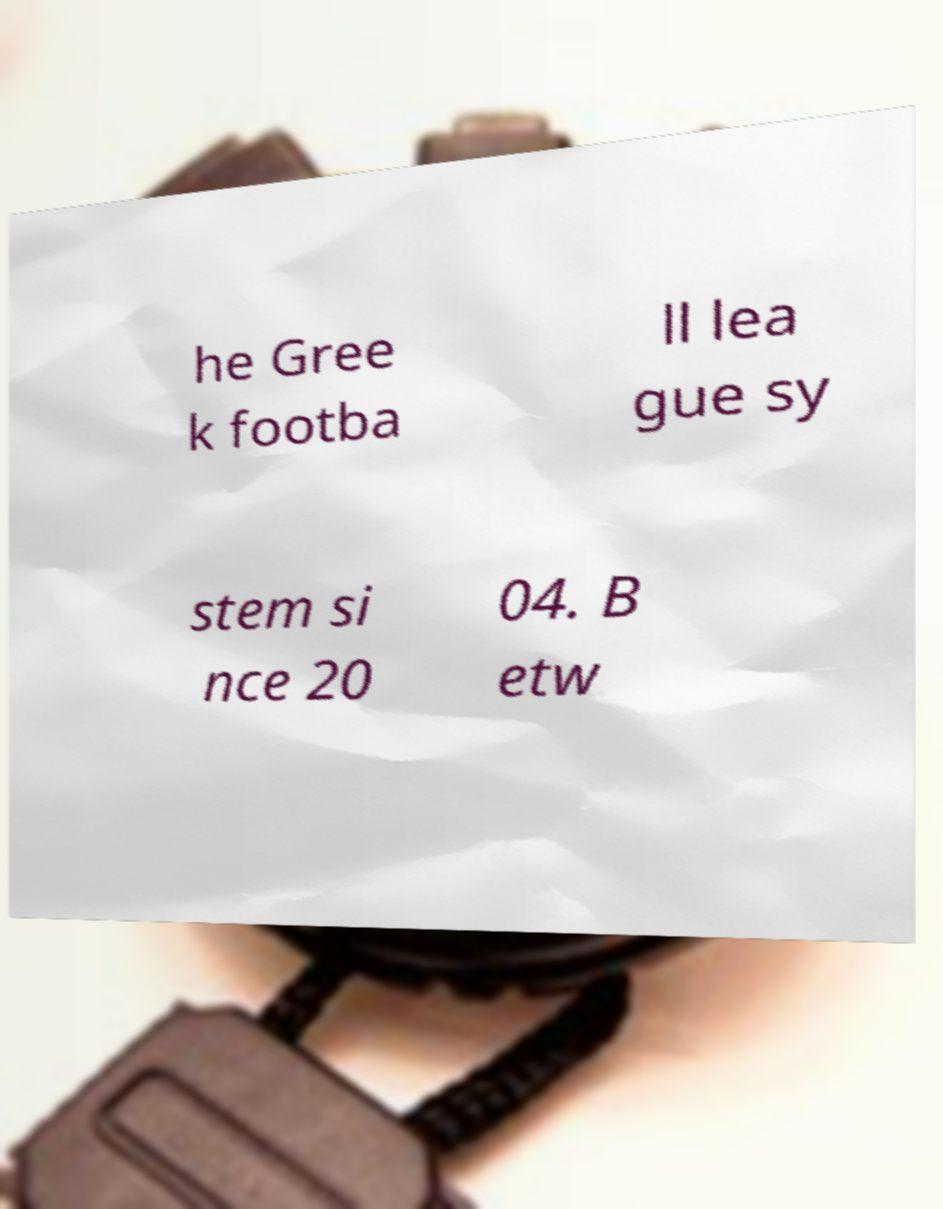Please identify and transcribe the text found in this image. he Gree k footba ll lea gue sy stem si nce 20 04. B etw 